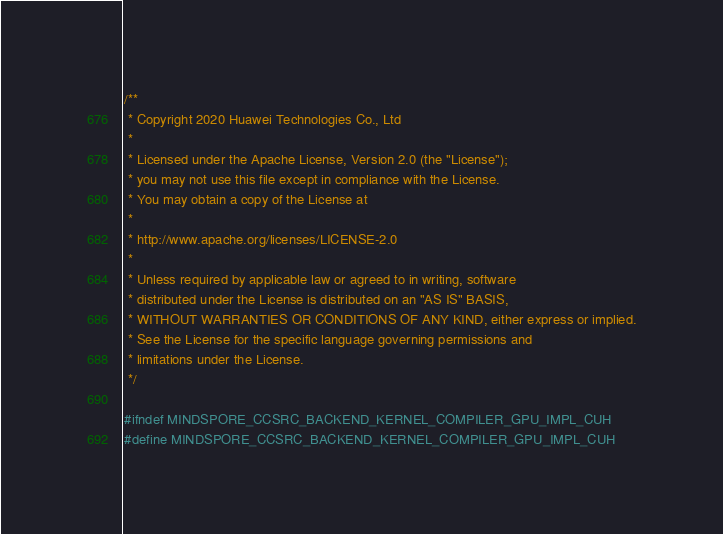Convert code to text. <code><loc_0><loc_0><loc_500><loc_500><_Cuda_>/**
 * Copyright 2020 Huawei Technologies Co., Ltd
 *
 * Licensed under the Apache License, Version 2.0 (the "License");
 * you may not use this file except in compliance with the License.
 * You may obtain a copy of the License at
 *
 * http://www.apache.org/licenses/LICENSE-2.0
 *
 * Unless required by applicable law or agreed to in writing, software
 * distributed under the License is distributed on an "AS IS" BASIS,
 * WITHOUT WARRANTIES OR CONDITIONS OF ANY KIND, either express or implied.
 * See the License for the specific language governing permissions and
 * limitations under the License.
 */

#ifndef MINDSPORE_CCSRC_BACKEND_KERNEL_COMPILER_GPU_IMPL_CUH
#define MINDSPORE_CCSRC_BACKEND_KERNEL_COMPILER_GPU_IMPL_CUH
</code> 